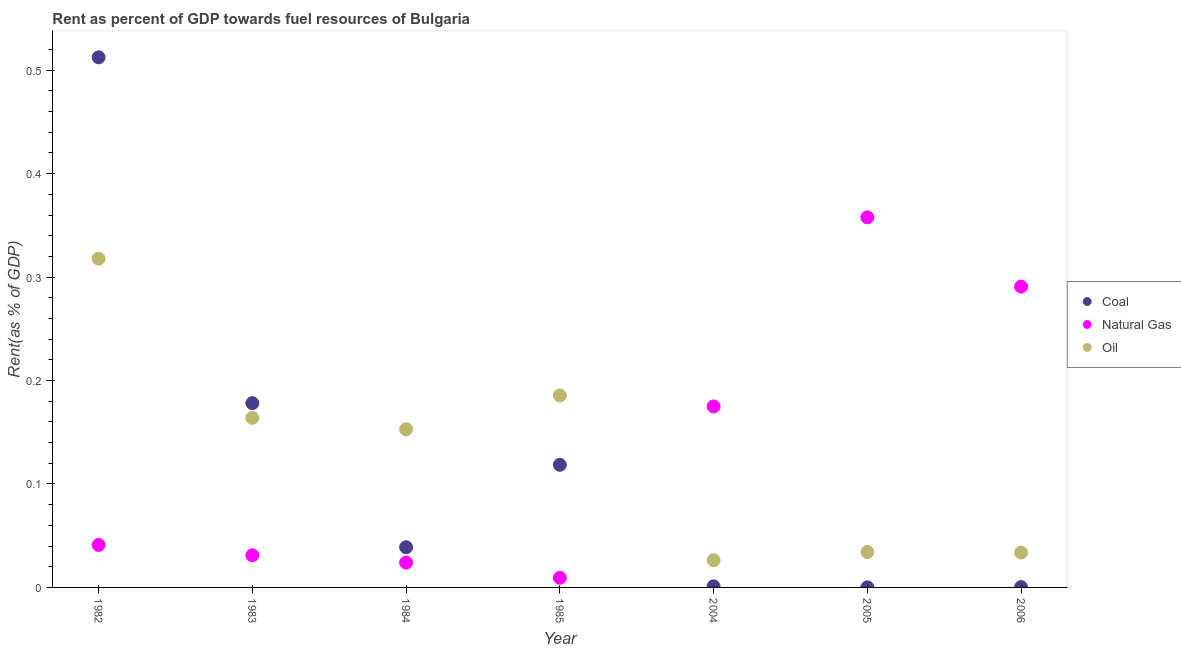Is the number of dotlines equal to the number of legend labels?
Your response must be concise. Yes. What is the rent towards oil in 2005?
Your response must be concise. 0.03. Across all years, what is the maximum rent towards coal?
Your answer should be compact. 0.51. Across all years, what is the minimum rent towards coal?
Your answer should be compact. 6.50114927236494e-5. What is the total rent towards natural gas in the graph?
Make the answer very short. 0.93. What is the difference between the rent towards oil in 1984 and that in 1985?
Provide a succinct answer. -0.03. What is the difference between the rent towards oil in 2006 and the rent towards coal in 2005?
Your answer should be very brief. 0.03. What is the average rent towards coal per year?
Keep it short and to the point. 0.12. In the year 2006, what is the difference between the rent towards coal and rent towards oil?
Your answer should be compact. -0.03. What is the ratio of the rent towards coal in 1982 to that in 1983?
Your response must be concise. 2.88. Is the rent towards coal in 1983 less than that in 2004?
Make the answer very short. No. Is the difference between the rent towards oil in 1984 and 2006 greater than the difference between the rent towards coal in 1984 and 2006?
Offer a very short reply. Yes. What is the difference between the highest and the second highest rent towards oil?
Provide a succinct answer. 0.13. What is the difference between the highest and the lowest rent towards coal?
Your answer should be compact. 0.51. Is it the case that in every year, the sum of the rent towards coal and rent towards natural gas is greater than the rent towards oil?
Your response must be concise. No. Is the rent towards oil strictly less than the rent towards natural gas over the years?
Keep it short and to the point. No. How many dotlines are there?
Keep it short and to the point. 3. How many years are there in the graph?
Give a very brief answer. 7. What is the difference between two consecutive major ticks on the Y-axis?
Your answer should be compact. 0.1. Does the graph contain any zero values?
Offer a terse response. No. Where does the legend appear in the graph?
Offer a terse response. Center right. How many legend labels are there?
Offer a terse response. 3. What is the title of the graph?
Offer a terse response. Rent as percent of GDP towards fuel resources of Bulgaria. What is the label or title of the Y-axis?
Offer a very short reply. Rent(as % of GDP). What is the Rent(as % of GDP) of Coal in 1982?
Provide a short and direct response. 0.51. What is the Rent(as % of GDP) in Natural Gas in 1982?
Make the answer very short. 0.04. What is the Rent(as % of GDP) of Oil in 1982?
Make the answer very short. 0.32. What is the Rent(as % of GDP) of Coal in 1983?
Your answer should be very brief. 0.18. What is the Rent(as % of GDP) in Natural Gas in 1983?
Make the answer very short. 0.03. What is the Rent(as % of GDP) in Oil in 1983?
Offer a terse response. 0.16. What is the Rent(as % of GDP) of Coal in 1984?
Your response must be concise. 0.04. What is the Rent(as % of GDP) in Natural Gas in 1984?
Provide a short and direct response. 0.02. What is the Rent(as % of GDP) of Oil in 1984?
Give a very brief answer. 0.15. What is the Rent(as % of GDP) of Coal in 1985?
Make the answer very short. 0.12. What is the Rent(as % of GDP) in Natural Gas in 1985?
Keep it short and to the point. 0.01. What is the Rent(as % of GDP) in Oil in 1985?
Offer a very short reply. 0.19. What is the Rent(as % of GDP) of Coal in 2004?
Offer a terse response. 0. What is the Rent(as % of GDP) of Natural Gas in 2004?
Your answer should be compact. 0.17. What is the Rent(as % of GDP) in Oil in 2004?
Keep it short and to the point. 0.03. What is the Rent(as % of GDP) of Coal in 2005?
Ensure brevity in your answer.  6.50114927236494e-5. What is the Rent(as % of GDP) of Natural Gas in 2005?
Your answer should be compact. 0.36. What is the Rent(as % of GDP) of Oil in 2005?
Your response must be concise. 0.03. What is the Rent(as % of GDP) in Coal in 2006?
Provide a short and direct response. 0. What is the Rent(as % of GDP) in Natural Gas in 2006?
Provide a short and direct response. 0.29. What is the Rent(as % of GDP) in Oil in 2006?
Offer a very short reply. 0.03. Across all years, what is the maximum Rent(as % of GDP) of Coal?
Your answer should be very brief. 0.51. Across all years, what is the maximum Rent(as % of GDP) of Natural Gas?
Your answer should be very brief. 0.36. Across all years, what is the maximum Rent(as % of GDP) in Oil?
Keep it short and to the point. 0.32. Across all years, what is the minimum Rent(as % of GDP) in Coal?
Ensure brevity in your answer.  6.50114927236494e-5. Across all years, what is the minimum Rent(as % of GDP) of Natural Gas?
Your response must be concise. 0.01. Across all years, what is the minimum Rent(as % of GDP) in Oil?
Give a very brief answer. 0.03. What is the total Rent(as % of GDP) of Coal in the graph?
Your answer should be compact. 0.85. What is the total Rent(as % of GDP) of Natural Gas in the graph?
Offer a very short reply. 0.93. What is the total Rent(as % of GDP) of Oil in the graph?
Make the answer very short. 0.91. What is the difference between the Rent(as % of GDP) of Coal in 1982 and that in 1983?
Your answer should be compact. 0.33. What is the difference between the Rent(as % of GDP) of Oil in 1982 and that in 1983?
Provide a short and direct response. 0.15. What is the difference between the Rent(as % of GDP) of Coal in 1982 and that in 1984?
Provide a succinct answer. 0.47. What is the difference between the Rent(as % of GDP) of Natural Gas in 1982 and that in 1984?
Offer a terse response. 0.02. What is the difference between the Rent(as % of GDP) in Oil in 1982 and that in 1984?
Offer a very short reply. 0.16. What is the difference between the Rent(as % of GDP) in Coal in 1982 and that in 1985?
Your answer should be very brief. 0.39. What is the difference between the Rent(as % of GDP) in Natural Gas in 1982 and that in 1985?
Your answer should be compact. 0.03. What is the difference between the Rent(as % of GDP) of Oil in 1982 and that in 1985?
Provide a succinct answer. 0.13. What is the difference between the Rent(as % of GDP) of Coal in 1982 and that in 2004?
Ensure brevity in your answer.  0.51. What is the difference between the Rent(as % of GDP) of Natural Gas in 1982 and that in 2004?
Ensure brevity in your answer.  -0.13. What is the difference between the Rent(as % of GDP) of Oil in 1982 and that in 2004?
Your answer should be very brief. 0.29. What is the difference between the Rent(as % of GDP) in Coal in 1982 and that in 2005?
Make the answer very short. 0.51. What is the difference between the Rent(as % of GDP) of Natural Gas in 1982 and that in 2005?
Offer a terse response. -0.32. What is the difference between the Rent(as % of GDP) in Oil in 1982 and that in 2005?
Your answer should be very brief. 0.28. What is the difference between the Rent(as % of GDP) in Coal in 1982 and that in 2006?
Provide a short and direct response. 0.51. What is the difference between the Rent(as % of GDP) of Natural Gas in 1982 and that in 2006?
Provide a succinct answer. -0.25. What is the difference between the Rent(as % of GDP) in Oil in 1982 and that in 2006?
Keep it short and to the point. 0.28. What is the difference between the Rent(as % of GDP) of Coal in 1983 and that in 1984?
Make the answer very short. 0.14. What is the difference between the Rent(as % of GDP) in Natural Gas in 1983 and that in 1984?
Give a very brief answer. 0.01. What is the difference between the Rent(as % of GDP) in Oil in 1983 and that in 1984?
Provide a short and direct response. 0.01. What is the difference between the Rent(as % of GDP) of Coal in 1983 and that in 1985?
Ensure brevity in your answer.  0.06. What is the difference between the Rent(as % of GDP) of Natural Gas in 1983 and that in 1985?
Provide a short and direct response. 0.02. What is the difference between the Rent(as % of GDP) in Oil in 1983 and that in 1985?
Your answer should be compact. -0.02. What is the difference between the Rent(as % of GDP) of Coal in 1983 and that in 2004?
Your answer should be compact. 0.18. What is the difference between the Rent(as % of GDP) in Natural Gas in 1983 and that in 2004?
Your answer should be very brief. -0.14. What is the difference between the Rent(as % of GDP) of Oil in 1983 and that in 2004?
Make the answer very short. 0.14. What is the difference between the Rent(as % of GDP) in Coal in 1983 and that in 2005?
Your answer should be compact. 0.18. What is the difference between the Rent(as % of GDP) in Natural Gas in 1983 and that in 2005?
Offer a terse response. -0.33. What is the difference between the Rent(as % of GDP) of Oil in 1983 and that in 2005?
Ensure brevity in your answer.  0.13. What is the difference between the Rent(as % of GDP) of Coal in 1983 and that in 2006?
Provide a short and direct response. 0.18. What is the difference between the Rent(as % of GDP) of Natural Gas in 1983 and that in 2006?
Your answer should be compact. -0.26. What is the difference between the Rent(as % of GDP) in Oil in 1983 and that in 2006?
Provide a succinct answer. 0.13. What is the difference between the Rent(as % of GDP) in Coal in 1984 and that in 1985?
Provide a short and direct response. -0.08. What is the difference between the Rent(as % of GDP) of Natural Gas in 1984 and that in 1985?
Provide a succinct answer. 0.01. What is the difference between the Rent(as % of GDP) in Oil in 1984 and that in 1985?
Provide a short and direct response. -0.03. What is the difference between the Rent(as % of GDP) in Coal in 1984 and that in 2004?
Provide a short and direct response. 0.04. What is the difference between the Rent(as % of GDP) of Natural Gas in 1984 and that in 2004?
Your response must be concise. -0.15. What is the difference between the Rent(as % of GDP) in Oil in 1984 and that in 2004?
Your answer should be compact. 0.13. What is the difference between the Rent(as % of GDP) in Coal in 1984 and that in 2005?
Your answer should be compact. 0.04. What is the difference between the Rent(as % of GDP) in Natural Gas in 1984 and that in 2005?
Your answer should be compact. -0.33. What is the difference between the Rent(as % of GDP) in Oil in 1984 and that in 2005?
Offer a terse response. 0.12. What is the difference between the Rent(as % of GDP) of Coal in 1984 and that in 2006?
Ensure brevity in your answer.  0.04. What is the difference between the Rent(as % of GDP) of Natural Gas in 1984 and that in 2006?
Make the answer very short. -0.27. What is the difference between the Rent(as % of GDP) of Oil in 1984 and that in 2006?
Keep it short and to the point. 0.12. What is the difference between the Rent(as % of GDP) in Coal in 1985 and that in 2004?
Ensure brevity in your answer.  0.12. What is the difference between the Rent(as % of GDP) in Natural Gas in 1985 and that in 2004?
Your answer should be compact. -0.17. What is the difference between the Rent(as % of GDP) in Oil in 1985 and that in 2004?
Your response must be concise. 0.16. What is the difference between the Rent(as % of GDP) in Coal in 1985 and that in 2005?
Provide a succinct answer. 0.12. What is the difference between the Rent(as % of GDP) of Natural Gas in 1985 and that in 2005?
Ensure brevity in your answer.  -0.35. What is the difference between the Rent(as % of GDP) of Oil in 1985 and that in 2005?
Your answer should be compact. 0.15. What is the difference between the Rent(as % of GDP) of Coal in 1985 and that in 2006?
Provide a short and direct response. 0.12. What is the difference between the Rent(as % of GDP) of Natural Gas in 1985 and that in 2006?
Make the answer very short. -0.28. What is the difference between the Rent(as % of GDP) in Oil in 1985 and that in 2006?
Keep it short and to the point. 0.15. What is the difference between the Rent(as % of GDP) of Coal in 2004 and that in 2005?
Offer a terse response. 0. What is the difference between the Rent(as % of GDP) in Natural Gas in 2004 and that in 2005?
Ensure brevity in your answer.  -0.18. What is the difference between the Rent(as % of GDP) in Oil in 2004 and that in 2005?
Your response must be concise. -0.01. What is the difference between the Rent(as % of GDP) of Coal in 2004 and that in 2006?
Your answer should be very brief. 0. What is the difference between the Rent(as % of GDP) in Natural Gas in 2004 and that in 2006?
Offer a terse response. -0.12. What is the difference between the Rent(as % of GDP) in Oil in 2004 and that in 2006?
Provide a short and direct response. -0.01. What is the difference between the Rent(as % of GDP) in Coal in 2005 and that in 2006?
Your response must be concise. -0. What is the difference between the Rent(as % of GDP) of Natural Gas in 2005 and that in 2006?
Ensure brevity in your answer.  0.07. What is the difference between the Rent(as % of GDP) of Oil in 2005 and that in 2006?
Make the answer very short. 0. What is the difference between the Rent(as % of GDP) of Coal in 1982 and the Rent(as % of GDP) of Natural Gas in 1983?
Offer a terse response. 0.48. What is the difference between the Rent(as % of GDP) of Coal in 1982 and the Rent(as % of GDP) of Oil in 1983?
Give a very brief answer. 0.35. What is the difference between the Rent(as % of GDP) in Natural Gas in 1982 and the Rent(as % of GDP) in Oil in 1983?
Your response must be concise. -0.12. What is the difference between the Rent(as % of GDP) in Coal in 1982 and the Rent(as % of GDP) in Natural Gas in 1984?
Give a very brief answer. 0.49. What is the difference between the Rent(as % of GDP) of Coal in 1982 and the Rent(as % of GDP) of Oil in 1984?
Provide a short and direct response. 0.36. What is the difference between the Rent(as % of GDP) of Natural Gas in 1982 and the Rent(as % of GDP) of Oil in 1984?
Your answer should be compact. -0.11. What is the difference between the Rent(as % of GDP) of Coal in 1982 and the Rent(as % of GDP) of Natural Gas in 1985?
Make the answer very short. 0.5. What is the difference between the Rent(as % of GDP) of Coal in 1982 and the Rent(as % of GDP) of Oil in 1985?
Offer a terse response. 0.33. What is the difference between the Rent(as % of GDP) in Natural Gas in 1982 and the Rent(as % of GDP) in Oil in 1985?
Make the answer very short. -0.14. What is the difference between the Rent(as % of GDP) of Coal in 1982 and the Rent(as % of GDP) of Natural Gas in 2004?
Your answer should be compact. 0.34. What is the difference between the Rent(as % of GDP) in Coal in 1982 and the Rent(as % of GDP) in Oil in 2004?
Your answer should be very brief. 0.49. What is the difference between the Rent(as % of GDP) in Natural Gas in 1982 and the Rent(as % of GDP) in Oil in 2004?
Give a very brief answer. 0.01. What is the difference between the Rent(as % of GDP) in Coal in 1982 and the Rent(as % of GDP) in Natural Gas in 2005?
Offer a very short reply. 0.15. What is the difference between the Rent(as % of GDP) of Coal in 1982 and the Rent(as % of GDP) of Oil in 2005?
Your response must be concise. 0.48. What is the difference between the Rent(as % of GDP) of Natural Gas in 1982 and the Rent(as % of GDP) of Oil in 2005?
Keep it short and to the point. 0.01. What is the difference between the Rent(as % of GDP) in Coal in 1982 and the Rent(as % of GDP) in Natural Gas in 2006?
Your answer should be compact. 0.22. What is the difference between the Rent(as % of GDP) of Coal in 1982 and the Rent(as % of GDP) of Oil in 2006?
Offer a very short reply. 0.48. What is the difference between the Rent(as % of GDP) of Natural Gas in 1982 and the Rent(as % of GDP) of Oil in 2006?
Offer a terse response. 0.01. What is the difference between the Rent(as % of GDP) in Coal in 1983 and the Rent(as % of GDP) in Natural Gas in 1984?
Your answer should be compact. 0.15. What is the difference between the Rent(as % of GDP) in Coal in 1983 and the Rent(as % of GDP) in Oil in 1984?
Your answer should be very brief. 0.03. What is the difference between the Rent(as % of GDP) in Natural Gas in 1983 and the Rent(as % of GDP) in Oil in 1984?
Make the answer very short. -0.12. What is the difference between the Rent(as % of GDP) in Coal in 1983 and the Rent(as % of GDP) in Natural Gas in 1985?
Provide a succinct answer. 0.17. What is the difference between the Rent(as % of GDP) in Coal in 1983 and the Rent(as % of GDP) in Oil in 1985?
Offer a very short reply. -0.01. What is the difference between the Rent(as % of GDP) of Natural Gas in 1983 and the Rent(as % of GDP) of Oil in 1985?
Keep it short and to the point. -0.15. What is the difference between the Rent(as % of GDP) in Coal in 1983 and the Rent(as % of GDP) in Natural Gas in 2004?
Your response must be concise. 0. What is the difference between the Rent(as % of GDP) in Coal in 1983 and the Rent(as % of GDP) in Oil in 2004?
Offer a terse response. 0.15. What is the difference between the Rent(as % of GDP) in Natural Gas in 1983 and the Rent(as % of GDP) in Oil in 2004?
Your answer should be very brief. 0. What is the difference between the Rent(as % of GDP) of Coal in 1983 and the Rent(as % of GDP) of Natural Gas in 2005?
Ensure brevity in your answer.  -0.18. What is the difference between the Rent(as % of GDP) in Coal in 1983 and the Rent(as % of GDP) in Oil in 2005?
Provide a short and direct response. 0.14. What is the difference between the Rent(as % of GDP) in Natural Gas in 1983 and the Rent(as % of GDP) in Oil in 2005?
Ensure brevity in your answer.  -0. What is the difference between the Rent(as % of GDP) of Coal in 1983 and the Rent(as % of GDP) of Natural Gas in 2006?
Offer a very short reply. -0.11. What is the difference between the Rent(as % of GDP) in Coal in 1983 and the Rent(as % of GDP) in Oil in 2006?
Your answer should be compact. 0.14. What is the difference between the Rent(as % of GDP) in Natural Gas in 1983 and the Rent(as % of GDP) in Oil in 2006?
Provide a short and direct response. -0. What is the difference between the Rent(as % of GDP) of Coal in 1984 and the Rent(as % of GDP) of Natural Gas in 1985?
Offer a very short reply. 0.03. What is the difference between the Rent(as % of GDP) in Coal in 1984 and the Rent(as % of GDP) in Oil in 1985?
Provide a succinct answer. -0.15. What is the difference between the Rent(as % of GDP) of Natural Gas in 1984 and the Rent(as % of GDP) of Oil in 1985?
Your response must be concise. -0.16. What is the difference between the Rent(as % of GDP) in Coal in 1984 and the Rent(as % of GDP) in Natural Gas in 2004?
Provide a short and direct response. -0.14. What is the difference between the Rent(as % of GDP) in Coal in 1984 and the Rent(as % of GDP) in Oil in 2004?
Provide a short and direct response. 0.01. What is the difference between the Rent(as % of GDP) in Natural Gas in 1984 and the Rent(as % of GDP) in Oil in 2004?
Provide a short and direct response. -0. What is the difference between the Rent(as % of GDP) in Coal in 1984 and the Rent(as % of GDP) in Natural Gas in 2005?
Provide a short and direct response. -0.32. What is the difference between the Rent(as % of GDP) of Coal in 1984 and the Rent(as % of GDP) of Oil in 2005?
Ensure brevity in your answer.  0. What is the difference between the Rent(as % of GDP) in Natural Gas in 1984 and the Rent(as % of GDP) in Oil in 2005?
Make the answer very short. -0.01. What is the difference between the Rent(as % of GDP) of Coal in 1984 and the Rent(as % of GDP) of Natural Gas in 2006?
Make the answer very short. -0.25. What is the difference between the Rent(as % of GDP) of Coal in 1984 and the Rent(as % of GDP) of Oil in 2006?
Make the answer very short. 0.01. What is the difference between the Rent(as % of GDP) of Natural Gas in 1984 and the Rent(as % of GDP) of Oil in 2006?
Give a very brief answer. -0.01. What is the difference between the Rent(as % of GDP) of Coal in 1985 and the Rent(as % of GDP) of Natural Gas in 2004?
Ensure brevity in your answer.  -0.06. What is the difference between the Rent(as % of GDP) of Coal in 1985 and the Rent(as % of GDP) of Oil in 2004?
Provide a succinct answer. 0.09. What is the difference between the Rent(as % of GDP) of Natural Gas in 1985 and the Rent(as % of GDP) of Oil in 2004?
Your answer should be very brief. -0.02. What is the difference between the Rent(as % of GDP) in Coal in 1985 and the Rent(as % of GDP) in Natural Gas in 2005?
Give a very brief answer. -0.24. What is the difference between the Rent(as % of GDP) in Coal in 1985 and the Rent(as % of GDP) in Oil in 2005?
Keep it short and to the point. 0.08. What is the difference between the Rent(as % of GDP) in Natural Gas in 1985 and the Rent(as % of GDP) in Oil in 2005?
Your answer should be compact. -0.02. What is the difference between the Rent(as % of GDP) in Coal in 1985 and the Rent(as % of GDP) in Natural Gas in 2006?
Make the answer very short. -0.17. What is the difference between the Rent(as % of GDP) of Coal in 1985 and the Rent(as % of GDP) of Oil in 2006?
Your answer should be compact. 0.08. What is the difference between the Rent(as % of GDP) in Natural Gas in 1985 and the Rent(as % of GDP) in Oil in 2006?
Your answer should be compact. -0.02. What is the difference between the Rent(as % of GDP) of Coal in 2004 and the Rent(as % of GDP) of Natural Gas in 2005?
Your answer should be compact. -0.36. What is the difference between the Rent(as % of GDP) in Coal in 2004 and the Rent(as % of GDP) in Oil in 2005?
Make the answer very short. -0.03. What is the difference between the Rent(as % of GDP) of Natural Gas in 2004 and the Rent(as % of GDP) of Oil in 2005?
Your response must be concise. 0.14. What is the difference between the Rent(as % of GDP) of Coal in 2004 and the Rent(as % of GDP) of Natural Gas in 2006?
Ensure brevity in your answer.  -0.29. What is the difference between the Rent(as % of GDP) in Coal in 2004 and the Rent(as % of GDP) in Oil in 2006?
Give a very brief answer. -0.03. What is the difference between the Rent(as % of GDP) in Natural Gas in 2004 and the Rent(as % of GDP) in Oil in 2006?
Provide a short and direct response. 0.14. What is the difference between the Rent(as % of GDP) of Coal in 2005 and the Rent(as % of GDP) of Natural Gas in 2006?
Your answer should be very brief. -0.29. What is the difference between the Rent(as % of GDP) in Coal in 2005 and the Rent(as % of GDP) in Oil in 2006?
Give a very brief answer. -0.03. What is the difference between the Rent(as % of GDP) in Natural Gas in 2005 and the Rent(as % of GDP) in Oil in 2006?
Your answer should be very brief. 0.32. What is the average Rent(as % of GDP) of Coal per year?
Keep it short and to the point. 0.12. What is the average Rent(as % of GDP) in Natural Gas per year?
Your answer should be very brief. 0.13. What is the average Rent(as % of GDP) of Oil per year?
Your answer should be compact. 0.13. In the year 1982, what is the difference between the Rent(as % of GDP) in Coal and Rent(as % of GDP) in Natural Gas?
Your answer should be compact. 0.47. In the year 1982, what is the difference between the Rent(as % of GDP) of Coal and Rent(as % of GDP) of Oil?
Ensure brevity in your answer.  0.19. In the year 1982, what is the difference between the Rent(as % of GDP) of Natural Gas and Rent(as % of GDP) of Oil?
Keep it short and to the point. -0.28. In the year 1983, what is the difference between the Rent(as % of GDP) in Coal and Rent(as % of GDP) in Natural Gas?
Make the answer very short. 0.15. In the year 1983, what is the difference between the Rent(as % of GDP) in Coal and Rent(as % of GDP) in Oil?
Make the answer very short. 0.01. In the year 1983, what is the difference between the Rent(as % of GDP) of Natural Gas and Rent(as % of GDP) of Oil?
Your answer should be very brief. -0.13. In the year 1984, what is the difference between the Rent(as % of GDP) in Coal and Rent(as % of GDP) in Natural Gas?
Make the answer very short. 0.01. In the year 1984, what is the difference between the Rent(as % of GDP) of Coal and Rent(as % of GDP) of Oil?
Ensure brevity in your answer.  -0.11. In the year 1984, what is the difference between the Rent(as % of GDP) of Natural Gas and Rent(as % of GDP) of Oil?
Provide a succinct answer. -0.13. In the year 1985, what is the difference between the Rent(as % of GDP) in Coal and Rent(as % of GDP) in Natural Gas?
Provide a short and direct response. 0.11. In the year 1985, what is the difference between the Rent(as % of GDP) in Coal and Rent(as % of GDP) in Oil?
Make the answer very short. -0.07. In the year 1985, what is the difference between the Rent(as % of GDP) in Natural Gas and Rent(as % of GDP) in Oil?
Offer a very short reply. -0.18. In the year 2004, what is the difference between the Rent(as % of GDP) of Coal and Rent(as % of GDP) of Natural Gas?
Your answer should be very brief. -0.17. In the year 2004, what is the difference between the Rent(as % of GDP) in Coal and Rent(as % of GDP) in Oil?
Keep it short and to the point. -0.03. In the year 2004, what is the difference between the Rent(as % of GDP) in Natural Gas and Rent(as % of GDP) in Oil?
Keep it short and to the point. 0.15. In the year 2005, what is the difference between the Rent(as % of GDP) in Coal and Rent(as % of GDP) in Natural Gas?
Ensure brevity in your answer.  -0.36. In the year 2005, what is the difference between the Rent(as % of GDP) in Coal and Rent(as % of GDP) in Oil?
Give a very brief answer. -0.03. In the year 2005, what is the difference between the Rent(as % of GDP) in Natural Gas and Rent(as % of GDP) in Oil?
Provide a short and direct response. 0.32. In the year 2006, what is the difference between the Rent(as % of GDP) in Coal and Rent(as % of GDP) in Natural Gas?
Offer a terse response. -0.29. In the year 2006, what is the difference between the Rent(as % of GDP) in Coal and Rent(as % of GDP) in Oil?
Provide a succinct answer. -0.03. In the year 2006, what is the difference between the Rent(as % of GDP) of Natural Gas and Rent(as % of GDP) of Oil?
Your answer should be compact. 0.26. What is the ratio of the Rent(as % of GDP) in Coal in 1982 to that in 1983?
Give a very brief answer. 2.88. What is the ratio of the Rent(as % of GDP) in Natural Gas in 1982 to that in 1983?
Provide a short and direct response. 1.32. What is the ratio of the Rent(as % of GDP) of Oil in 1982 to that in 1983?
Provide a short and direct response. 1.94. What is the ratio of the Rent(as % of GDP) in Coal in 1982 to that in 1984?
Keep it short and to the point. 13.2. What is the ratio of the Rent(as % of GDP) in Natural Gas in 1982 to that in 1984?
Offer a very short reply. 1.71. What is the ratio of the Rent(as % of GDP) in Oil in 1982 to that in 1984?
Ensure brevity in your answer.  2.08. What is the ratio of the Rent(as % of GDP) of Coal in 1982 to that in 1985?
Offer a terse response. 4.32. What is the ratio of the Rent(as % of GDP) in Natural Gas in 1982 to that in 1985?
Offer a very short reply. 4.39. What is the ratio of the Rent(as % of GDP) in Oil in 1982 to that in 1985?
Offer a terse response. 1.71. What is the ratio of the Rent(as % of GDP) in Coal in 1982 to that in 2004?
Offer a very short reply. 488.55. What is the ratio of the Rent(as % of GDP) in Natural Gas in 1982 to that in 2004?
Your answer should be very brief. 0.23. What is the ratio of the Rent(as % of GDP) in Oil in 1982 to that in 2004?
Your answer should be very brief. 12.07. What is the ratio of the Rent(as % of GDP) of Coal in 1982 to that in 2005?
Offer a terse response. 7882.14. What is the ratio of the Rent(as % of GDP) in Natural Gas in 1982 to that in 2005?
Offer a terse response. 0.11. What is the ratio of the Rent(as % of GDP) in Oil in 1982 to that in 2005?
Ensure brevity in your answer.  9.28. What is the ratio of the Rent(as % of GDP) in Coal in 1982 to that in 2006?
Provide a short and direct response. 1814.56. What is the ratio of the Rent(as % of GDP) of Natural Gas in 1982 to that in 2006?
Provide a short and direct response. 0.14. What is the ratio of the Rent(as % of GDP) of Oil in 1982 to that in 2006?
Your response must be concise. 9.42. What is the ratio of the Rent(as % of GDP) of Coal in 1983 to that in 1984?
Ensure brevity in your answer.  4.59. What is the ratio of the Rent(as % of GDP) in Natural Gas in 1983 to that in 1984?
Make the answer very short. 1.29. What is the ratio of the Rent(as % of GDP) in Oil in 1983 to that in 1984?
Your answer should be very brief. 1.07. What is the ratio of the Rent(as % of GDP) of Coal in 1983 to that in 1985?
Provide a succinct answer. 1.5. What is the ratio of the Rent(as % of GDP) in Natural Gas in 1983 to that in 1985?
Make the answer very short. 3.32. What is the ratio of the Rent(as % of GDP) in Oil in 1983 to that in 1985?
Provide a short and direct response. 0.88. What is the ratio of the Rent(as % of GDP) of Coal in 1983 to that in 2004?
Your response must be concise. 169.84. What is the ratio of the Rent(as % of GDP) in Natural Gas in 1983 to that in 2004?
Give a very brief answer. 0.18. What is the ratio of the Rent(as % of GDP) of Oil in 1983 to that in 2004?
Your answer should be compact. 6.23. What is the ratio of the Rent(as % of GDP) in Coal in 1983 to that in 2005?
Offer a terse response. 2740.11. What is the ratio of the Rent(as % of GDP) of Natural Gas in 1983 to that in 2005?
Keep it short and to the point. 0.09. What is the ratio of the Rent(as % of GDP) of Oil in 1983 to that in 2005?
Your answer should be compact. 4.79. What is the ratio of the Rent(as % of GDP) in Coal in 1983 to that in 2006?
Give a very brief answer. 630.81. What is the ratio of the Rent(as % of GDP) of Natural Gas in 1983 to that in 2006?
Your answer should be compact. 0.11. What is the ratio of the Rent(as % of GDP) of Oil in 1983 to that in 2006?
Offer a terse response. 4.86. What is the ratio of the Rent(as % of GDP) in Coal in 1984 to that in 1985?
Your response must be concise. 0.33. What is the ratio of the Rent(as % of GDP) in Natural Gas in 1984 to that in 1985?
Offer a terse response. 2.57. What is the ratio of the Rent(as % of GDP) in Oil in 1984 to that in 1985?
Offer a terse response. 0.82. What is the ratio of the Rent(as % of GDP) in Coal in 1984 to that in 2004?
Provide a succinct answer. 37.03. What is the ratio of the Rent(as % of GDP) in Natural Gas in 1984 to that in 2004?
Make the answer very short. 0.14. What is the ratio of the Rent(as % of GDP) of Oil in 1984 to that in 2004?
Provide a short and direct response. 5.81. What is the ratio of the Rent(as % of GDP) in Coal in 1984 to that in 2005?
Your response must be concise. 597.36. What is the ratio of the Rent(as % of GDP) of Natural Gas in 1984 to that in 2005?
Keep it short and to the point. 0.07. What is the ratio of the Rent(as % of GDP) in Oil in 1984 to that in 2005?
Your answer should be very brief. 4.47. What is the ratio of the Rent(as % of GDP) in Coal in 1984 to that in 2006?
Your answer should be compact. 137.52. What is the ratio of the Rent(as % of GDP) of Natural Gas in 1984 to that in 2006?
Make the answer very short. 0.08. What is the ratio of the Rent(as % of GDP) in Oil in 1984 to that in 2006?
Provide a short and direct response. 4.53. What is the ratio of the Rent(as % of GDP) in Coal in 1985 to that in 2004?
Provide a succinct answer. 113.04. What is the ratio of the Rent(as % of GDP) in Natural Gas in 1985 to that in 2004?
Make the answer very short. 0.05. What is the ratio of the Rent(as % of GDP) of Oil in 1985 to that in 2004?
Keep it short and to the point. 7.05. What is the ratio of the Rent(as % of GDP) in Coal in 1985 to that in 2005?
Keep it short and to the point. 1823.69. What is the ratio of the Rent(as % of GDP) of Natural Gas in 1985 to that in 2005?
Give a very brief answer. 0.03. What is the ratio of the Rent(as % of GDP) in Oil in 1985 to that in 2005?
Your answer should be compact. 5.42. What is the ratio of the Rent(as % of GDP) in Coal in 1985 to that in 2006?
Give a very brief answer. 419.83. What is the ratio of the Rent(as % of GDP) of Natural Gas in 1985 to that in 2006?
Offer a very short reply. 0.03. What is the ratio of the Rent(as % of GDP) in Oil in 1985 to that in 2006?
Your response must be concise. 5.5. What is the ratio of the Rent(as % of GDP) in Coal in 2004 to that in 2005?
Keep it short and to the point. 16.13. What is the ratio of the Rent(as % of GDP) in Natural Gas in 2004 to that in 2005?
Provide a succinct answer. 0.49. What is the ratio of the Rent(as % of GDP) in Oil in 2004 to that in 2005?
Keep it short and to the point. 0.77. What is the ratio of the Rent(as % of GDP) of Coal in 2004 to that in 2006?
Provide a succinct answer. 3.71. What is the ratio of the Rent(as % of GDP) of Natural Gas in 2004 to that in 2006?
Provide a succinct answer. 0.6. What is the ratio of the Rent(as % of GDP) in Oil in 2004 to that in 2006?
Your response must be concise. 0.78. What is the ratio of the Rent(as % of GDP) of Coal in 2005 to that in 2006?
Your answer should be very brief. 0.23. What is the ratio of the Rent(as % of GDP) of Natural Gas in 2005 to that in 2006?
Make the answer very short. 1.23. What is the ratio of the Rent(as % of GDP) in Oil in 2005 to that in 2006?
Give a very brief answer. 1.01. What is the difference between the highest and the second highest Rent(as % of GDP) of Coal?
Ensure brevity in your answer.  0.33. What is the difference between the highest and the second highest Rent(as % of GDP) of Natural Gas?
Keep it short and to the point. 0.07. What is the difference between the highest and the second highest Rent(as % of GDP) of Oil?
Give a very brief answer. 0.13. What is the difference between the highest and the lowest Rent(as % of GDP) in Coal?
Ensure brevity in your answer.  0.51. What is the difference between the highest and the lowest Rent(as % of GDP) in Natural Gas?
Make the answer very short. 0.35. What is the difference between the highest and the lowest Rent(as % of GDP) in Oil?
Provide a succinct answer. 0.29. 